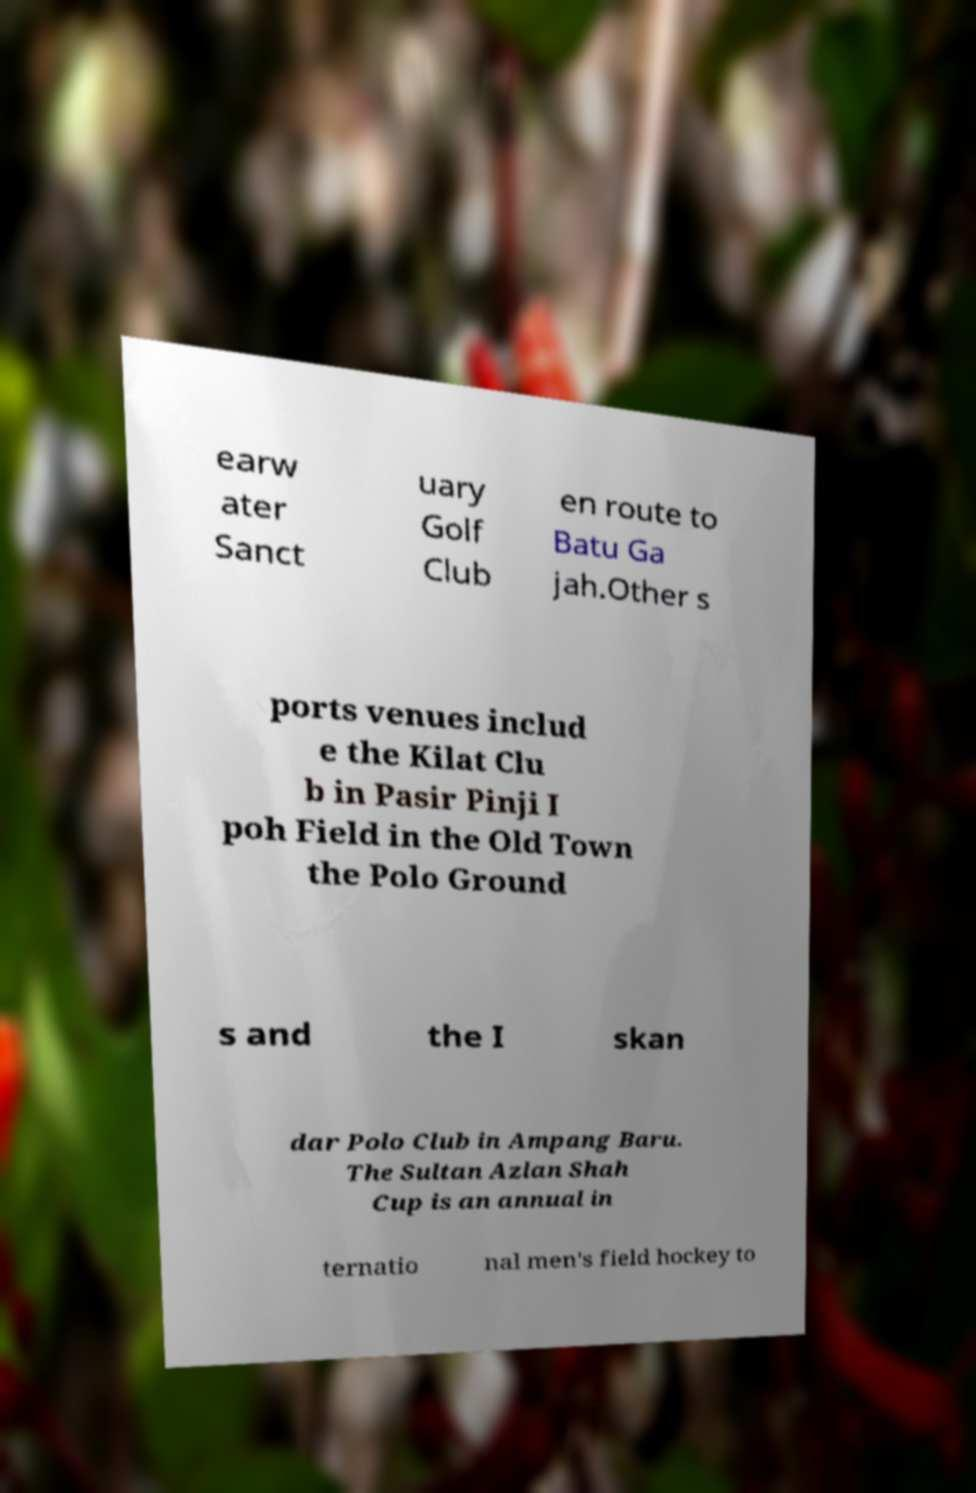For documentation purposes, I need the text within this image transcribed. Could you provide that? earw ater Sanct uary Golf Club en route to Batu Ga jah.Other s ports venues includ e the Kilat Clu b in Pasir Pinji I poh Field in the Old Town the Polo Ground s and the I skan dar Polo Club in Ampang Baru. The Sultan Azlan Shah Cup is an annual in ternatio nal men's field hockey to 